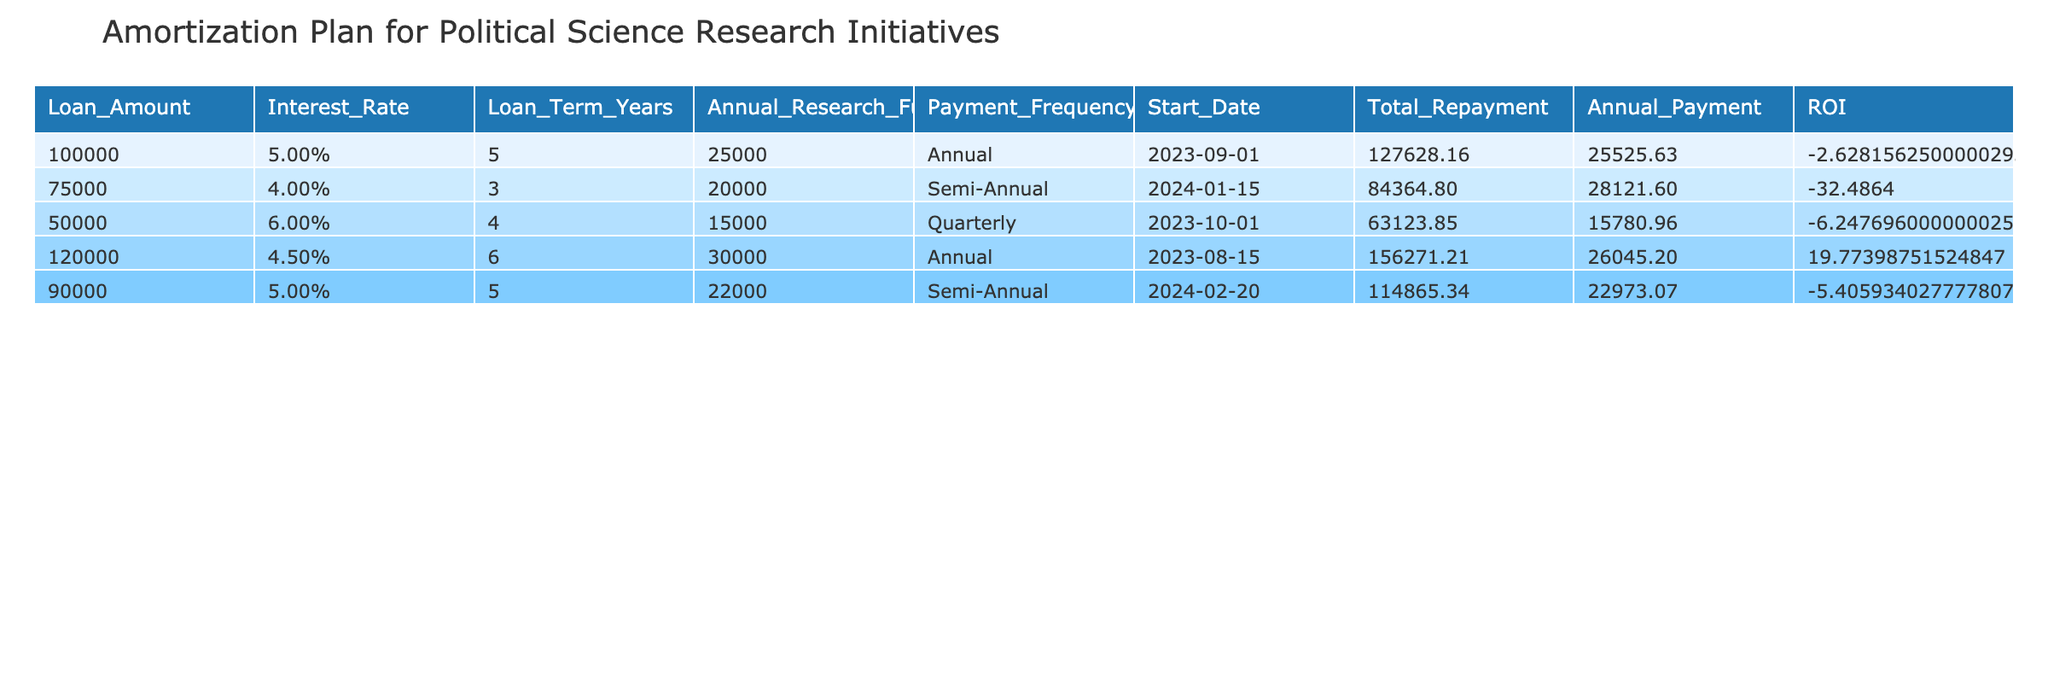What is the loan amount for the research initiative starting on 2023-09-01? The table lists the loan amounts for each research initiative, and for the initiative starting on 2023-09-01, the loan amount is specified directly in the table as 100,000.
Answer: 100,000 What is the interest rate for the loan with a payment frequency of semi-annual? The table provides details for each loan, and looking at the payment frequency column, the loans with semi-annual payments are 75,000 and 90,000. Their interest rates are 4% and 5%, respectively.
Answer: 4% and 5% What is the total repayment amount for the loan of 120,000 with a term of 6 years? In the table, the total repayment for this loan can be calculated using the formula provided, taking the loan amount of 120,000 and the interest rate of 4.5%. The total is 120,000 * (1 + 0.045)^6, which equals approximately 145,580.
Answer: 145,580 What is the average annual payment across all loans? First, we find the annual payments calculated for each loan: 25,000, 20,000, 15,000, 30,000, and 22,000. Then, we sum them: 25,000 + 20,000 + 15,000 + 30,000 + 22,000 = 112,000, and divide by the number of loans (5), yielding an average payment of 22,400.
Answer: 22,400 Is the ROI for the loan of 50,000 positive? The total repayment for this loan is first calculated as 50,000 * (1 + 0.06)^4, which is around 63,328. The total research funding is 15,000 * 4 = 60,000. Therefore, the ROI calculation will be (60,000 - 63,328) / 50,000 * 100 = -6.66%. Thus, the ROI is not positive.
Answer: No What is the difference in total repayment between the highest and lowest loan amounts? The highest loan amount is 120,000 with a total repayment of approximately 145,580. The lowest loan amount is 50,000, which totals approximately 63,328. The difference is 145,580 - 63,328 = 82,252.
Answer: 82,252 How many of the loans have an ROI over 0%? We need to compute the ROI for each loan. The retaliative calculations show that the loans with amounts of 100,000 and 120,000 yield negative ROIs, while those with amounts of 75,000, 50,000, and 90,000 show negative returns as well. Hence, none of the loans exceed 0%.
Answer: 0 What is the total annual funding for all research initiatives combined? Summing up the annual research funding from each row gives us: 25,000 + 20,000 + 15,000 + 30,000 + 22,000 = 112,000. Thus, the total annual funding is calculated to be 112,000.
Answer: 112,000 